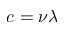Convert formula to latex. <formula><loc_0><loc_0><loc_500><loc_500>c = \nu \lambda</formula> 